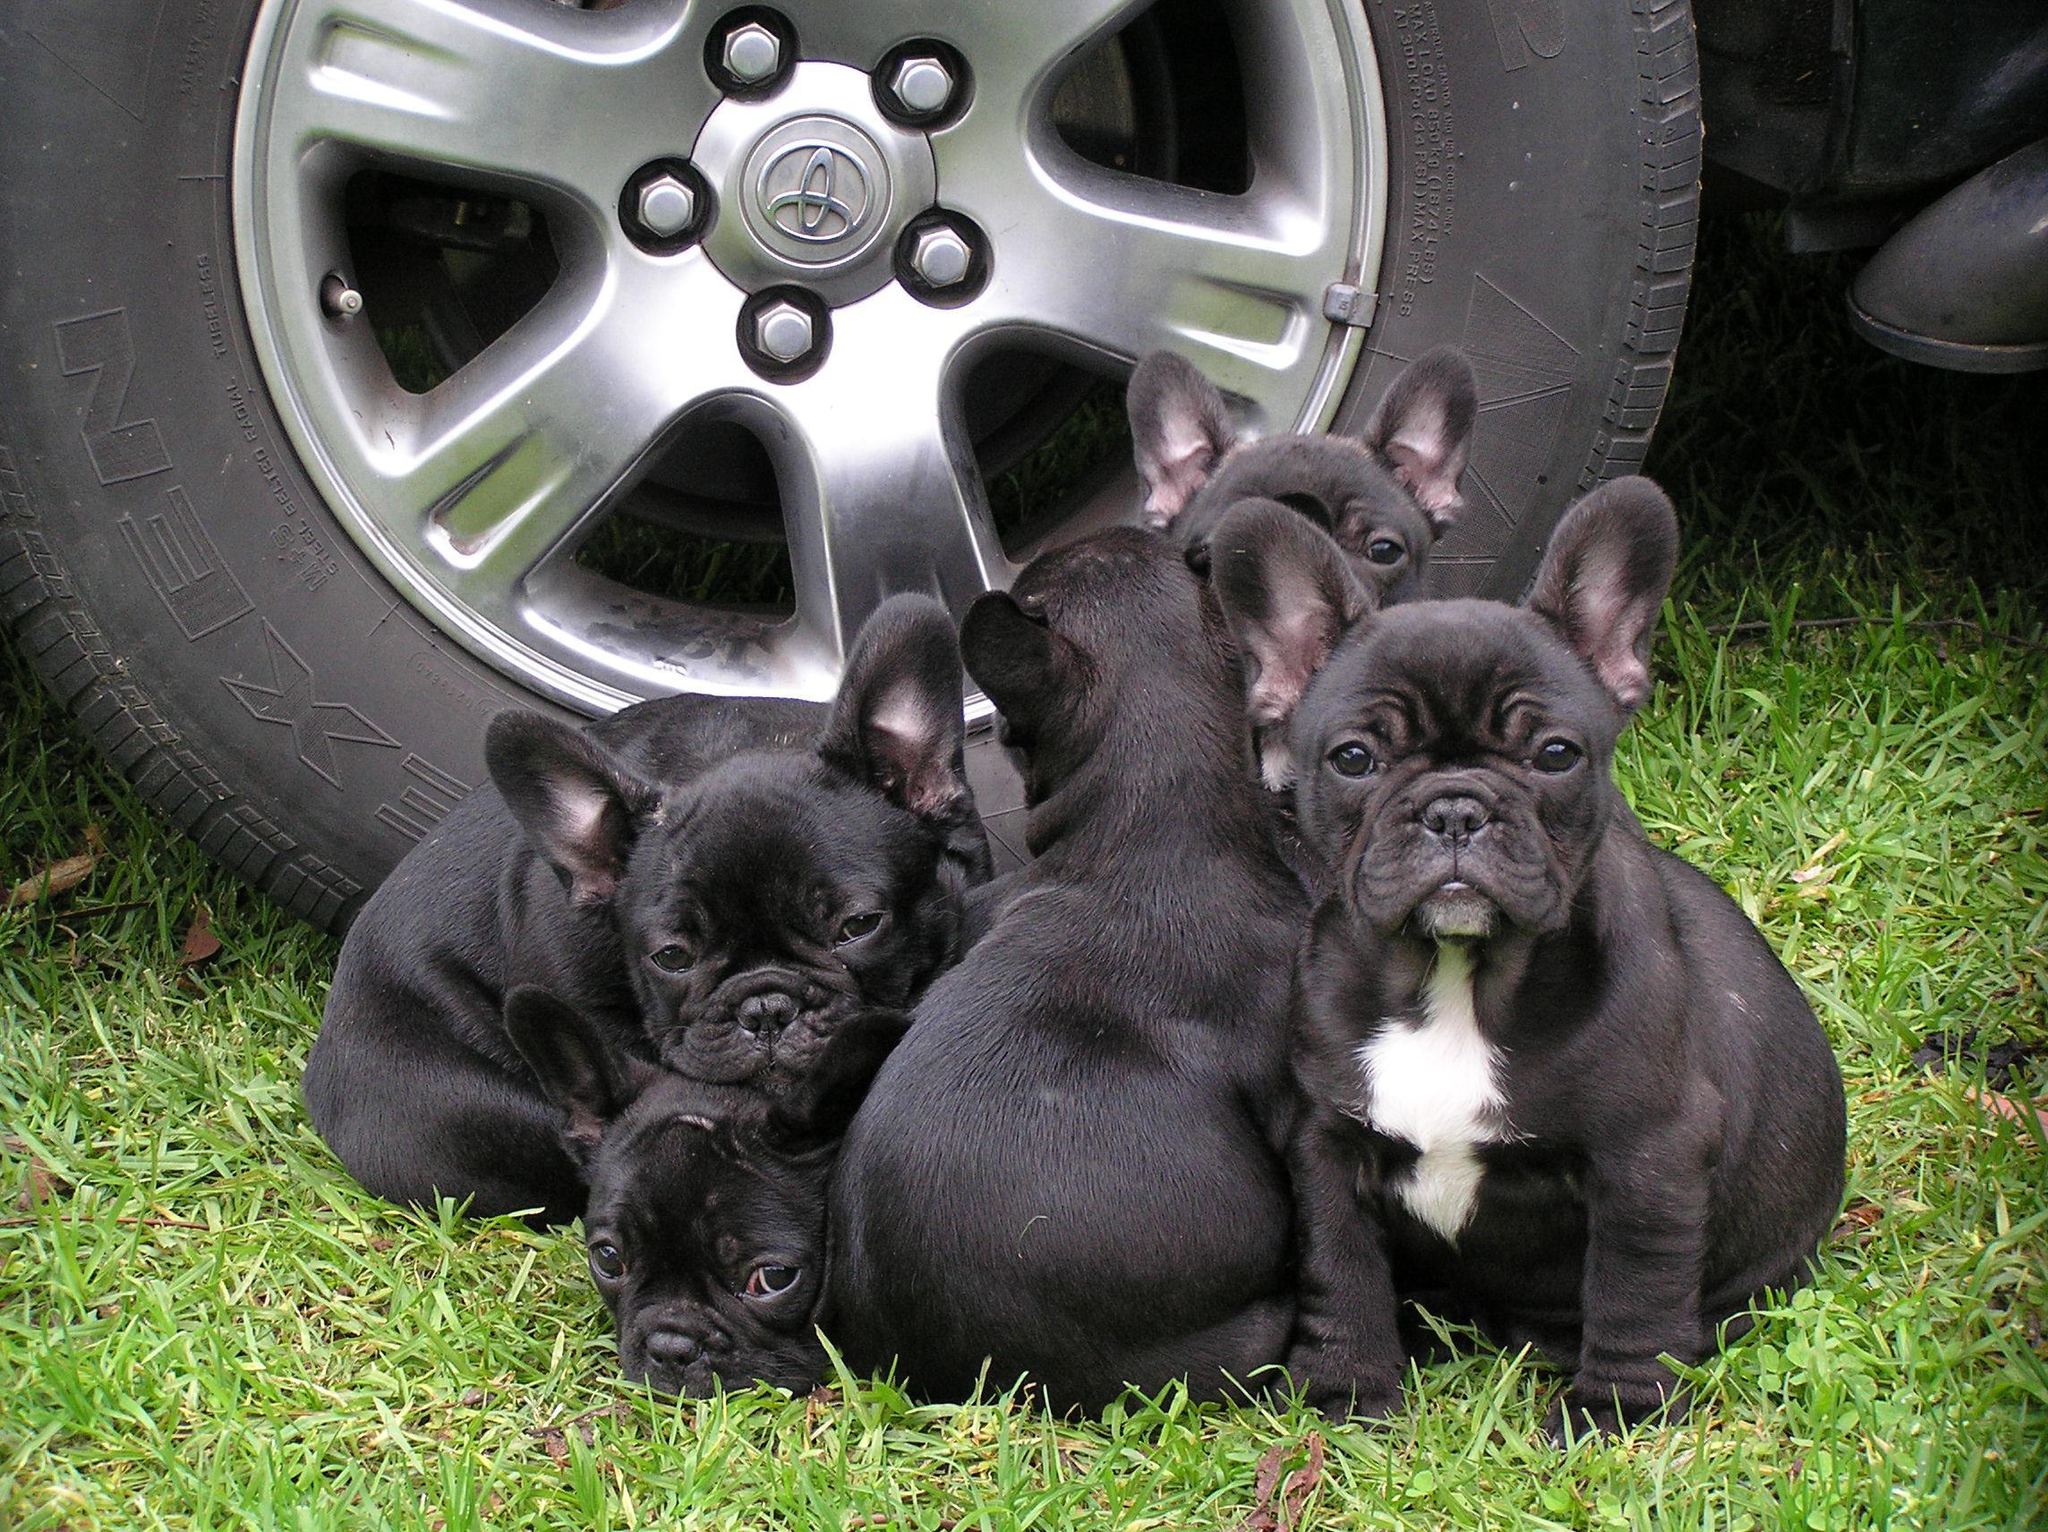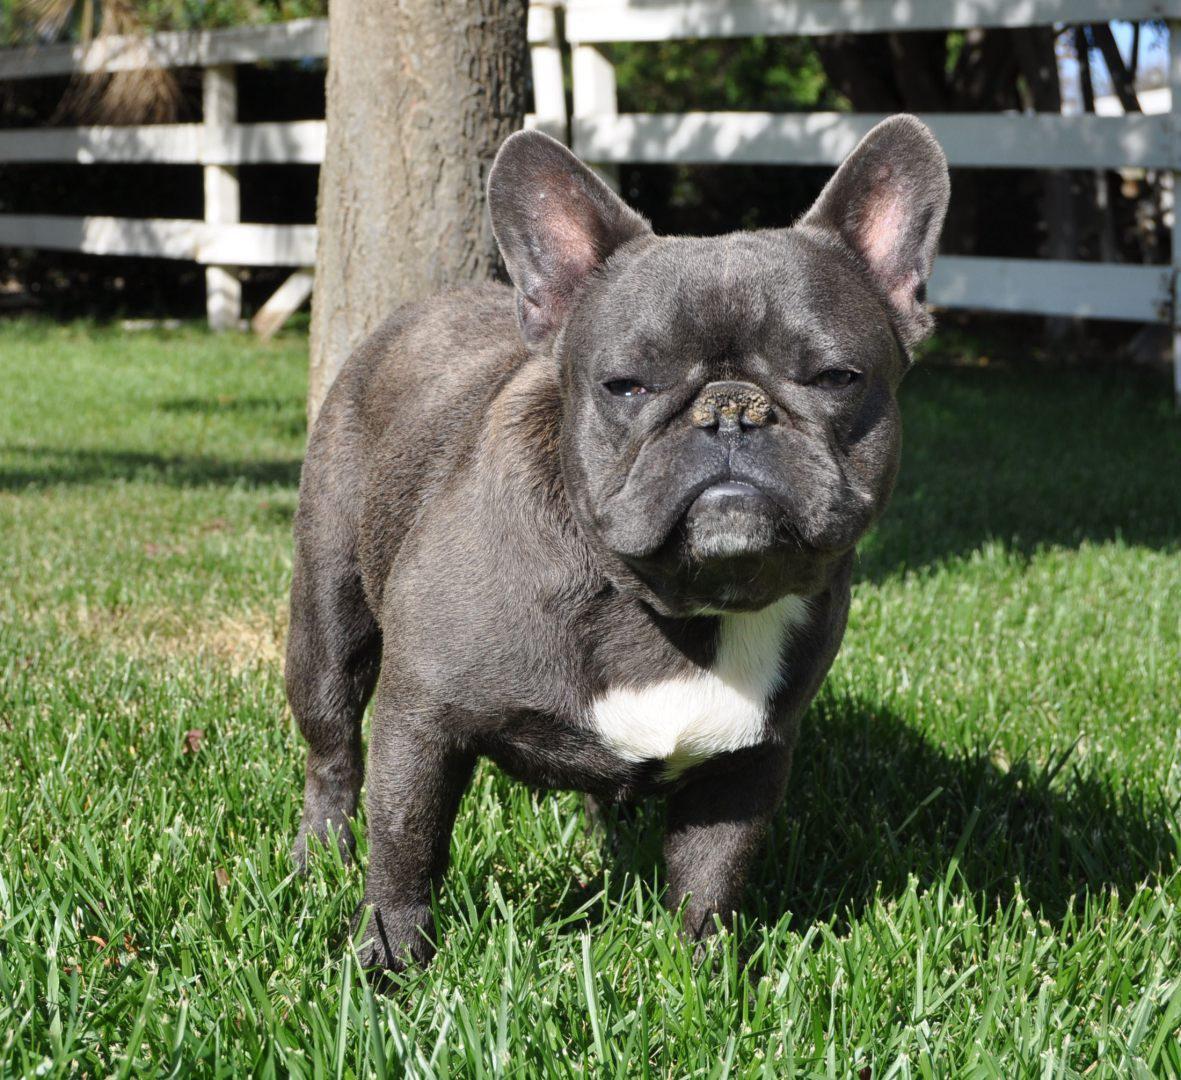The first image is the image on the left, the second image is the image on the right. Given the left and right images, does the statement "A single French Bulldog is standing up in the grass." hold true? Answer yes or no. Yes. 